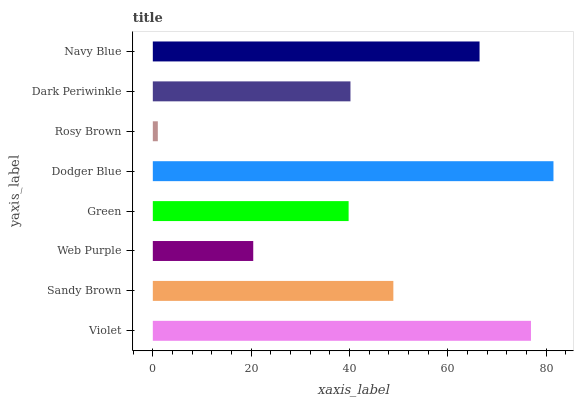Is Rosy Brown the minimum?
Answer yes or no. Yes. Is Dodger Blue the maximum?
Answer yes or no. Yes. Is Sandy Brown the minimum?
Answer yes or no. No. Is Sandy Brown the maximum?
Answer yes or no. No. Is Violet greater than Sandy Brown?
Answer yes or no. Yes. Is Sandy Brown less than Violet?
Answer yes or no. Yes. Is Sandy Brown greater than Violet?
Answer yes or no. No. Is Violet less than Sandy Brown?
Answer yes or no. No. Is Sandy Brown the high median?
Answer yes or no. Yes. Is Dark Periwinkle the low median?
Answer yes or no. Yes. Is Dodger Blue the high median?
Answer yes or no. No. Is Sandy Brown the low median?
Answer yes or no. No. 